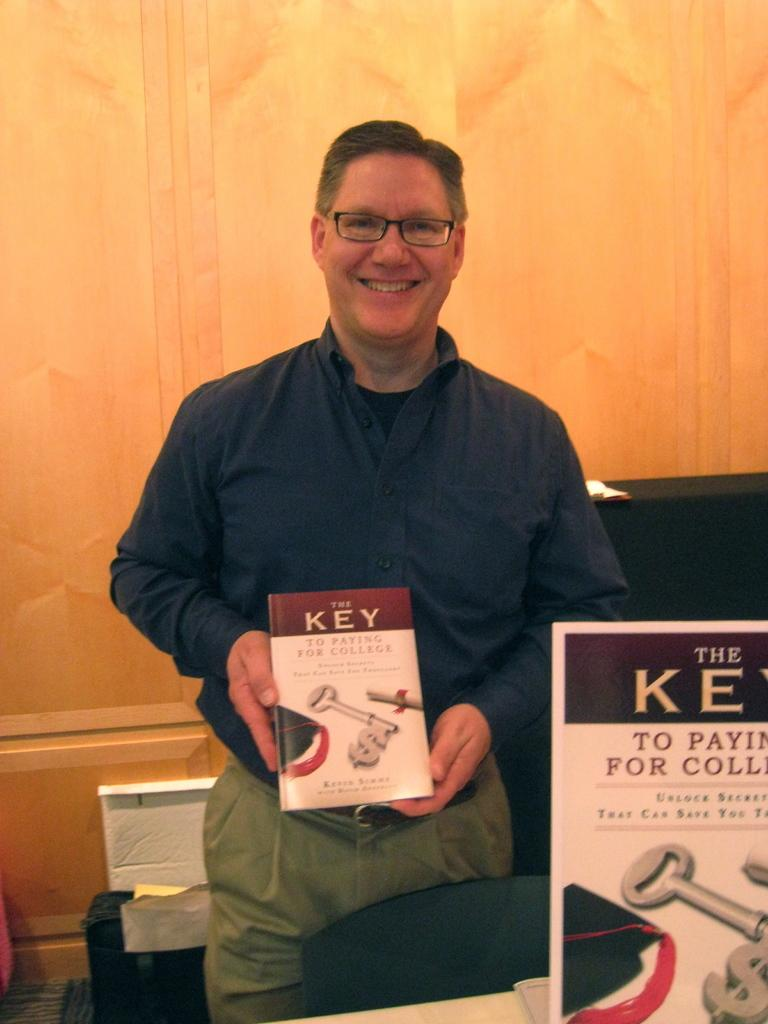<image>
Relay a brief, clear account of the picture shown. A man holds a book called The Key to Paying for College. 